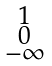Convert formula to latex. <formula><loc_0><loc_0><loc_500><loc_500>\begin{smallmatrix} 1 \\ 0 \\ - \infty \end{smallmatrix}</formula> 